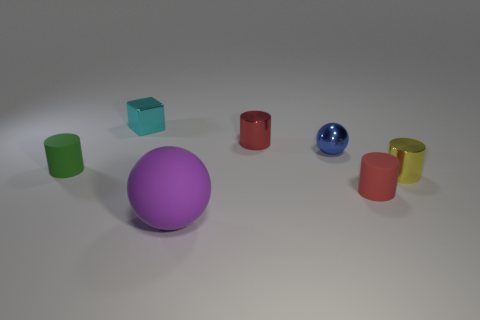Subtract 1 cylinders. How many cylinders are left? 3 Add 3 small gray cylinders. How many objects exist? 10 Subtract all spheres. How many objects are left? 5 Add 7 small matte objects. How many small matte objects are left? 9 Add 7 large blue rubber spheres. How many large blue rubber spheres exist? 7 Subtract 0 green spheres. How many objects are left? 7 Subtract all tiny yellow metallic cylinders. Subtract all small green objects. How many objects are left? 5 